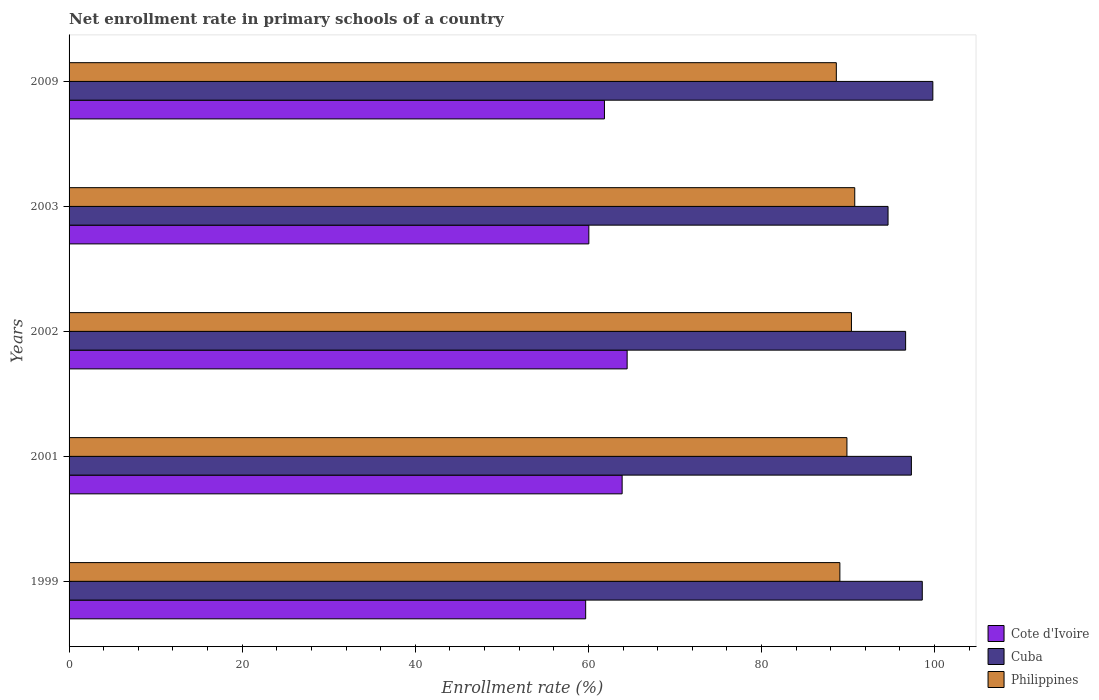How many different coloured bars are there?
Your response must be concise. 3. Are the number of bars per tick equal to the number of legend labels?
Make the answer very short. Yes. Are the number of bars on each tick of the Y-axis equal?
Keep it short and to the point. Yes. What is the label of the 2nd group of bars from the top?
Make the answer very short. 2003. What is the enrollment rate in primary schools in Cote d'Ivoire in 2001?
Provide a succinct answer. 63.9. Across all years, what is the maximum enrollment rate in primary schools in Cuba?
Your answer should be very brief. 99.8. Across all years, what is the minimum enrollment rate in primary schools in Cuba?
Your answer should be compact. 94.62. In which year was the enrollment rate in primary schools in Philippines maximum?
Provide a succinct answer. 2003. In which year was the enrollment rate in primary schools in Cote d'Ivoire minimum?
Provide a short and direct response. 1999. What is the total enrollment rate in primary schools in Cote d'Ivoire in the graph?
Offer a very short reply. 309.98. What is the difference between the enrollment rate in primary schools in Cote d'Ivoire in 2001 and that in 2002?
Your answer should be compact. -0.58. What is the difference between the enrollment rate in primary schools in Cote d'Ivoire in 2003 and the enrollment rate in primary schools in Philippines in 2002?
Your response must be concise. -30.34. What is the average enrollment rate in primary schools in Cote d'Ivoire per year?
Offer a terse response. 62. In the year 2001, what is the difference between the enrollment rate in primary schools in Cuba and enrollment rate in primary schools in Philippines?
Your answer should be very brief. 7.45. What is the ratio of the enrollment rate in primary schools in Cuba in 2001 to that in 2003?
Provide a succinct answer. 1.03. Is the enrollment rate in primary schools in Cote d'Ivoire in 1999 less than that in 2003?
Keep it short and to the point. Yes. Is the difference between the enrollment rate in primary schools in Cuba in 2001 and 2009 greater than the difference between the enrollment rate in primary schools in Philippines in 2001 and 2009?
Provide a short and direct response. No. What is the difference between the highest and the second highest enrollment rate in primary schools in Cuba?
Ensure brevity in your answer.  1.22. What is the difference between the highest and the lowest enrollment rate in primary schools in Cote d'Ivoire?
Offer a very short reply. 4.79. Is the sum of the enrollment rate in primary schools in Cote d'Ivoire in 2001 and 2003 greater than the maximum enrollment rate in primary schools in Philippines across all years?
Your answer should be very brief. Yes. What does the 2nd bar from the top in 2001 represents?
Provide a succinct answer. Cuba. What does the 1st bar from the bottom in 2001 represents?
Provide a short and direct response. Cote d'Ivoire. Are all the bars in the graph horizontal?
Your answer should be very brief. Yes. How many years are there in the graph?
Offer a very short reply. 5. What is the difference between two consecutive major ticks on the X-axis?
Your response must be concise. 20. Are the values on the major ticks of X-axis written in scientific E-notation?
Provide a succinct answer. No. Does the graph contain any zero values?
Provide a short and direct response. No. Does the graph contain grids?
Provide a succinct answer. No. Where does the legend appear in the graph?
Your response must be concise. Bottom right. How many legend labels are there?
Offer a very short reply. 3. How are the legend labels stacked?
Offer a very short reply. Vertical. What is the title of the graph?
Give a very brief answer. Net enrollment rate in primary schools of a country. What is the label or title of the X-axis?
Keep it short and to the point. Enrollment rate (%). What is the label or title of the Y-axis?
Keep it short and to the point. Years. What is the Enrollment rate (%) of Cote d'Ivoire in 1999?
Make the answer very short. 59.69. What is the Enrollment rate (%) of Cuba in 1999?
Give a very brief answer. 98.58. What is the Enrollment rate (%) in Philippines in 1999?
Provide a succinct answer. 89.06. What is the Enrollment rate (%) in Cote d'Ivoire in 2001?
Give a very brief answer. 63.9. What is the Enrollment rate (%) in Cuba in 2001?
Your response must be concise. 97.32. What is the Enrollment rate (%) of Philippines in 2001?
Provide a succinct answer. 89.87. What is the Enrollment rate (%) of Cote d'Ivoire in 2002?
Provide a short and direct response. 64.48. What is the Enrollment rate (%) of Cuba in 2002?
Offer a terse response. 96.65. What is the Enrollment rate (%) of Philippines in 2002?
Your answer should be very brief. 90.39. What is the Enrollment rate (%) in Cote d'Ivoire in 2003?
Offer a terse response. 60.05. What is the Enrollment rate (%) in Cuba in 2003?
Your answer should be compact. 94.62. What is the Enrollment rate (%) of Philippines in 2003?
Offer a terse response. 90.78. What is the Enrollment rate (%) of Cote d'Ivoire in 2009?
Offer a very short reply. 61.86. What is the Enrollment rate (%) of Cuba in 2009?
Provide a short and direct response. 99.8. What is the Enrollment rate (%) of Philippines in 2009?
Offer a very short reply. 88.65. Across all years, what is the maximum Enrollment rate (%) of Cote d'Ivoire?
Provide a short and direct response. 64.48. Across all years, what is the maximum Enrollment rate (%) of Cuba?
Provide a short and direct response. 99.8. Across all years, what is the maximum Enrollment rate (%) in Philippines?
Provide a succinct answer. 90.78. Across all years, what is the minimum Enrollment rate (%) of Cote d'Ivoire?
Provide a short and direct response. 59.69. Across all years, what is the minimum Enrollment rate (%) in Cuba?
Ensure brevity in your answer.  94.62. Across all years, what is the minimum Enrollment rate (%) in Philippines?
Offer a terse response. 88.65. What is the total Enrollment rate (%) in Cote d'Ivoire in the graph?
Offer a very short reply. 309.98. What is the total Enrollment rate (%) of Cuba in the graph?
Keep it short and to the point. 486.97. What is the total Enrollment rate (%) in Philippines in the graph?
Keep it short and to the point. 448.75. What is the difference between the Enrollment rate (%) in Cote d'Ivoire in 1999 and that in 2001?
Provide a succinct answer. -4.21. What is the difference between the Enrollment rate (%) in Cuba in 1999 and that in 2001?
Give a very brief answer. 1.26. What is the difference between the Enrollment rate (%) of Philippines in 1999 and that in 2001?
Your response must be concise. -0.82. What is the difference between the Enrollment rate (%) of Cote d'Ivoire in 1999 and that in 2002?
Your answer should be very brief. -4.79. What is the difference between the Enrollment rate (%) in Cuba in 1999 and that in 2002?
Your answer should be compact. 1.92. What is the difference between the Enrollment rate (%) of Philippines in 1999 and that in 2002?
Offer a terse response. -1.34. What is the difference between the Enrollment rate (%) in Cote d'Ivoire in 1999 and that in 2003?
Offer a very short reply. -0.37. What is the difference between the Enrollment rate (%) in Cuba in 1999 and that in 2003?
Ensure brevity in your answer.  3.95. What is the difference between the Enrollment rate (%) of Philippines in 1999 and that in 2003?
Provide a short and direct response. -1.72. What is the difference between the Enrollment rate (%) in Cote d'Ivoire in 1999 and that in 2009?
Your response must be concise. -2.17. What is the difference between the Enrollment rate (%) of Cuba in 1999 and that in 2009?
Keep it short and to the point. -1.22. What is the difference between the Enrollment rate (%) of Philippines in 1999 and that in 2009?
Your response must be concise. 0.41. What is the difference between the Enrollment rate (%) of Cote d'Ivoire in 2001 and that in 2002?
Offer a terse response. -0.58. What is the difference between the Enrollment rate (%) of Cuba in 2001 and that in 2002?
Your response must be concise. 0.67. What is the difference between the Enrollment rate (%) in Philippines in 2001 and that in 2002?
Offer a terse response. -0.52. What is the difference between the Enrollment rate (%) of Cote d'Ivoire in 2001 and that in 2003?
Your response must be concise. 3.85. What is the difference between the Enrollment rate (%) of Cuba in 2001 and that in 2003?
Your response must be concise. 2.7. What is the difference between the Enrollment rate (%) in Philippines in 2001 and that in 2003?
Offer a terse response. -0.9. What is the difference between the Enrollment rate (%) of Cote d'Ivoire in 2001 and that in 2009?
Make the answer very short. 2.04. What is the difference between the Enrollment rate (%) in Cuba in 2001 and that in 2009?
Make the answer very short. -2.48. What is the difference between the Enrollment rate (%) of Philippines in 2001 and that in 2009?
Your answer should be very brief. 1.23. What is the difference between the Enrollment rate (%) in Cote d'Ivoire in 2002 and that in 2003?
Give a very brief answer. 4.42. What is the difference between the Enrollment rate (%) of Cuba in 2002 and that in 2003?
Provide a short and direct response. 2.03. What is the difference between the Enrollment rate (%) in Philippines in 2002 and that in 2003?
Your answer should be very brief. -0.38. What is the difference between the Enrollment rate (%) in Cote d'Ivoire in 2002 and that in 2009?
Make the answer very short. 2.62. What is the difference between the Enrollment rate (%) of Cuba in 2002 and that in 2009?
Your answer should be very brief. -3.15. What is the difference between the Enrollment rate (%) in Philippines in 2002 and that in 2009?
Your answer should be very brief. 1.75. What is the difference between the Enrollment rate (%) of Cote d'Ivoire in 2003 and that in 2009?
Your answer should be very brief. -1.8. What is the difference between the Enrollment rate (%) of Cuba in 2003 and that in 2009?
Your answer should be compact. -5.18. What is the difference between the Enrollment rate (%) of Philippines in 2003 and that in 2009?
Your answer should be compact. 2.13. What is the difference between the Enrollment rate (%) of Cote d'Ivoire in 1999 and the Enrollment rate (%) of Cuba in 2001?
Offer a very short reply. -37.63. What is the difference between the Enrollment rate (%) in Cote d'Ivoire in 1999 and the Enrollment rate (%) in Philippines in 2001?
Offer a terse response. -30.19. What is the difference between the Enrollment rate (%) of Cuba in 1999 and the Enrollment rate (%) of Philippines in 2001?
Keep it short and to the point. 8.7. What is the difference between the Enrollment rate (%) of Cote d'Ivoire in 1999 and the Enrollment rate (%) of Cuba in 2002?
Your response must be concise. -36.97. What is the difference between the Enrollment rate (%) of Cote d'Ivoire in 1999 and the Enrollment rate (%) of Philippines in 2002?
Provide a short and direct response. -30.71. What is the difference between the Enrollment rate (%) in Cuba in 1999 and the Enrollment rate (%) in Philippines in 2002?
Keep it short and to the point. 8.18. What is the difference between the Enrollment rate (%) of Cote d'Ivoire in 1999 and the Enrollment rate (%) of Cuba in 2003?
Provide a short and direct response. -34.94. What is the difference between the Enrollment rate (%) of Cote d'Ivoire in 1999 and the Enrollment rate (%) of Philippines in 2003?
Ensure brevity in your answer.  -31.09. What is the difference between the Enrollment rate (%) in Cuba in 1999 and the Enrollment rate (%) in Philippines in 2003?
Make the answer very short. 7.8. What is the difference between the Enrollment rate (%) in Cote d'Ivoire in 1999 and the Enrollment rate (%) in Cuba in 2009?
Keep it short and to the point. -40.11. What is the difference between the Enrollment rate (%) in Cote d'Ivoire in 1999 and the Enrollment rate (%) in Philippines in 2009?
Your answer should be compact. -28.96. What is the difference between the Enrollment rate (%) in Cuba in 1999 and the Enrollment rate (%) in Philippines in 2009?
Keep it short and to the point. 9.93. What is the difference between the Enrollment rate (%) in Cote d'Ivoire in 2001 and the Enrollment rate (%) in Cuba in 2002?
Keep it short and to the point. -32.75. What is the difference between the Enrollment rate (%) in Cote d'Ivoire in 2001 and the Enrollment rate (%) in Philippines in 2002?
Your answer should be very brief. -26.49. What is the difference between the Enrollment rate (%) in Cuba in 2001 and the Enrollment rate (%) in Philippines in 2002?
Offer a very short reply. 6.93. What is the difference between the Enrollment rate (%) in Cote d'Ivoire in 2001 and the Enrollment rate (%) in Cuba in 2003?
Keep it short and to the point. -30.72. What is the difference between the Enrollment rate (%) in Cote d'Ivoire in 2001 and the Enrollment rate (%) in Philippines in 2003?
Offer a terse response. -26.87. What is the difference between the Enrollment rate (%) of Cuba in 2001 and the Enrollment rate (%) of Philippines in 2003?
Make the answer very short. 6.54. What is the difference between the Enrollment rate (%) of Cote d'Ivoire in 2001 and the Enrollment rate (%) of Cuba in 2009?
Your response must be concise. -35.9. What is the difference between the Enrollment rate (%) of Cote d'Ivoire in 2001 and the Enrollment rate (%) of Philippines in 2009?
Provide a short and direct response. -24.75. What is the difference between the Enrollment rate (%) of Cuba in 2001 and the Enrollment rate (%) of Philippines in 2009?
Your response must be concise. 8.67. What is the difference between the Enrollment rate (%) in Cote d'Ivoire in 2002 and the Enrollment rate (%) in Cuba in 2003?
Ensure brevity in your answer.  -30.15. What is the difference between the Enrollment rate (%) in Cote d'Ivoire in 2002 and the Enrollment rate (%) in Philippines in 2003?
Offer a very short reply. -26.3. What is the difference between the Enrollment rate (%) of Cuba in 2002 and the Enrollment rate (%) of Philippines in 2003?
Provide a succinct answer. 5.88. What is the difference between the Enrollment rate (%) in Cote d'Ivoire in 2002 and the Enrollment rate (%) in Cuba in 2009?
Offer a very short reply. -35.32. What is the difference between the Enrollment rate (%) of Cote d'Ivoire in 2002 and the Enrollment rate (%) of Philippines in 2009?
Your answer should be compact. -24.17. What is the difference between the Enrollment rate (%) in Cuba in 2002 and the Enrollment rate (%) in Philippines in 2009?
Your answer should be very brief. 8.01. What is the difference between the Enrollment rate (%) of Cote d'Ivoire in 2003 and the Enrollment rate (%) of Cuba in 2009?
Provide a short and direct response. -39.74. What is the difference between the Enrollment rate (%) in Cote d'Ivoire in 2003 and the Enrollment rate (%) in Philippines in 2009?
Your answer should be very brief. -28.59. What is the difference between the Enrollment rate (%) in Cuba in 2003 and the Enrollment rate (%) in Philippines in 2009?
Your answer should be compact. 5.98. What is the average Enrollment rate (%) of Cote d'Ivoire per year?
Your answer should be very brief. 62. What is the average Enrollment rate (%) in Cuba per year?
Your answer should be compact. 97.39. What is the average Enrollment rate (%) of Philippines per year?
Your answer should be compact. 89.75. In the year 1999, what is the difference between the Enrollment rate (%) of Cote d'Ivoire and Enrollment rate (%) of Cuba?
Offer a very short reply. -38.89. In the year 1999, what is the difference between the Enrollment rate (%) of Cote d'Ivoire and Enrollment rate (%) of Philippines?
Your response must be concise. -29.37. In the year 1999, what is the difference between the Enrollment rate (%) of Cuba and Enrollment rate (%) of Philippines?
Your answer should be compact. 9.52. In the year 2001, what is the difference between the Enrollment rate (%) of Cote d'Ivoire and Enrollment rate (%) of Cuba?
Your response must be concise. -33.42. In the year 2001, what is the difference between the Enrollment rate (%) of Cote d'Ivoire and Enrollment rate (%) of Philippines?
Your answer should be very brief. -25.97. In the year 2001, what is the difference between the Enrollment rate (%) in Cuba and Enrollment rate (%) in Philippines?
Make the answer very short. 7.45. In the year 2002, what is the difference between the Enrollment rate (%) in Cote d'Ivoire and Enrollment rate (%) in Cuba?
Ensure brevity in your answer.  -32.18. In the year 2002, what is the difference between the Enrollment rate (%) in Cote d'Ivoire and Enrollment rate (%) in Philippines?
Provide a short and direct response. -25.92. In the year 2002, what is the difference between the Enrollment rate (%) of Cuba and Enrollment rate (%) of Philippines?
Make the answer very short. 6.26. In the year 2003, what is the difference between the Enrollment rate (%) in Cote d'Ivoire and Enrollment rate (%) in Cuba?
Provide a short and direct response. -34.57. In the year 2003, what is the difference between the Enrollment rate (%) of Cote d'Ivoire and Enrollment rate (%) of Philippines?
Your answer should be compact. -30.72. In the year 2003, what is the difference between the Enrollment rate (%) of Cuba and Enrollment rate (%) of Philippines?
Give a very brief answer. 3.85. In the year 2009, what is the difference between the Enrollment rate (%) in Cote d'Ivoire and Enrollment rate (%) in Cuba?
Provide a short and direct response. -37.94. In the year 2009, what is the difference between the Enrollment rate (%) of Cote d'Ivoire and Enrollment rate (%) of Philippines?
Offer a very short reply. -26.79. In the year 2009, what is the difference between the Enrollment rate (%) of Cuba and Enrollment rate (%) of Philippines?
Keep it short and to the point. 11.15. What is the ratio of the Enrollment rate (%) of Cote d'Ivoire in 1999 to that in 2001?
Make the answer very short. 0.93. What is the ratio of the Enrollment rate (%) of Cuba in 1999 to that in 2001?
Offer a very short reply. 1.01. What is the ratio of the Enrollment rate (%) of Philippines in 1999 to that in 2001?
Your response must be concise. 0.99. What is the ratio of the Enrollment rate (%) in Cote d'Ivoire in 1999 to that in 2002?
Make the answer very short. 0.93. What is the ratio of the Enrollment rate (%) in Cuba in 1999 to that in 2002?
Give a very brief answer. 1.02. What is the ratio of the Enrollment rate (%) in Philippines in 1999 to that in 2002?
Provide a short and direct response. 0.99. What is the ratio of the Enrollment rate (%) of Cote d'Ivoire in 1999 to that in 2003?
Offer a very short reply. 0.99. What is the ratio of the Enrollment rate (%) of Cuba in 1999 to that in 2003?
Your response must be concise. 1.04. What is the ratio of the Enrollment rate (%) in Philippines in 1999 to that in 2003?
Give a very brief answer. 0.98. What is the ratio of the Enrollment rate (%) of Cote d'Ivoire in 1999 to that in 2009?
Offer a terse response. 0.96. What is the ratio of the Enrollment rate (%) of Cuba in 1999 to that in 2009?
Keep it short and to the point. 0.99. What is the ratio of the Enrollment rate (%) of Philippines in 1999 to that in 2009?
Make the answer very short. 1. What is the ratio of the Enrollment rate (%) in Cuba in 2001 to that in 2002?
Offer a terse response. 1.01. What is the ratio of the Enrollment rate (%) of Cote d'Ivoire in 2001 to that in 2003?
Give a very brief answer. 1.06. What is the ratio of the Enrollment rate (%) in Cuba in 2001 to that in 2003?
Ensure brevity in your answer.  1.03. What is the ratio of the Enrollment rate (%) of Philippines in 2001 to that in 2003?
Offer a very short reply. 0.99. What is the ratio of the Enrollment rate (%) in Cote d'Ivoire in 2001 to that in 2009?
Offer a terse response. 1.03. What is the ratio of the Enrollment rate (%) in Cuba in 2001 to that in 2009?
Ensure brevity in your answer.  0.98. What is the ratio of the Enrollment rate (%) in Philippines in 2001 to that in 2009?
Your response must be concise. 1.01. What is the ratio of the Enrollment rate (%) in Cote d'Ivoire in 2002 to that in 2003?
Ensure brevity in your answer.  1.07. What is the ratio of the Enrollment rate (%) of Cuba in 2002 to that in 2003?
Offer a very short reply. 1.02. What is the ratio of the Enrollment rate (%) of Cote d'Ivoire in 2002 to that in 2009?
Offer a terse response. 1.04. What is the ratio of the Enrollment rate (%) in Cuba in 2002 to that in 2009?
Provide a succinct answer. 0.97. What is the ratio of the Enrollment rate (%) of Philippines in 2002 to that in 2009?
Your answer should be compact. 1.02. What is the ratio of the Enrollment rate (%) in Cote d'Ivoire in 2003 to that in 2009?
Provide a succinct answer. 0.97. What is the ratio of the Enrollment rate (%) of Cuba in 2003 to that in 2009?
Your response must be concise. 0.95. What is the difference between the highest and the second highest Enrollment rate (%) in Cote d'Ivoire?
Offer a terse response. 0.58. What is the difference between the highest and the second highest Enrollment rate (%) of Cuba?
Ensure brevity in your answer.  1.22. What is the difference between the highest and the second highest Enrollment rate (%) of Philippines?
Provide a short and direct response. 0.38. What is the difference between the highest and the lowest Enrollment rate (%) in Cote d'Ivoire?
Your answer should be very brief. 4.79. What is the difference between the highest and the lowest Enrollment rate (%) of Cuba?
Ensure brevity in your answer.  5.18. What is the difference between the highest and the lowest Enrollment rate (%) of Philippines?
Offer a very short reply. 2.13. 